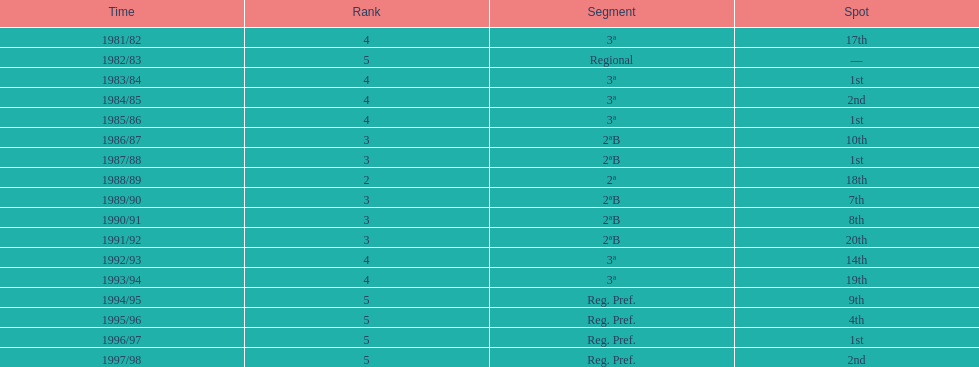When is the last year that the team has been division 2? 1991/92. 